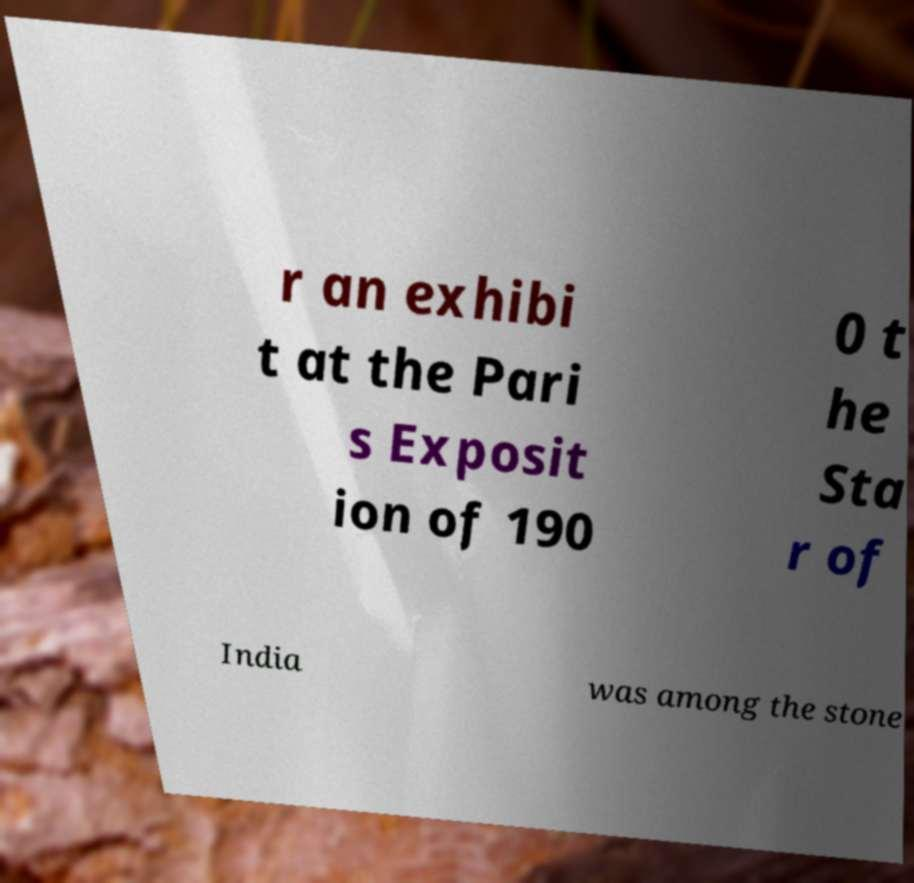Could you assist in decoding the text presented in this image and type it out clearly? r an exhibi t at the Pari s Exposit ion of 190 0 t he Sta r of India was among the stone 